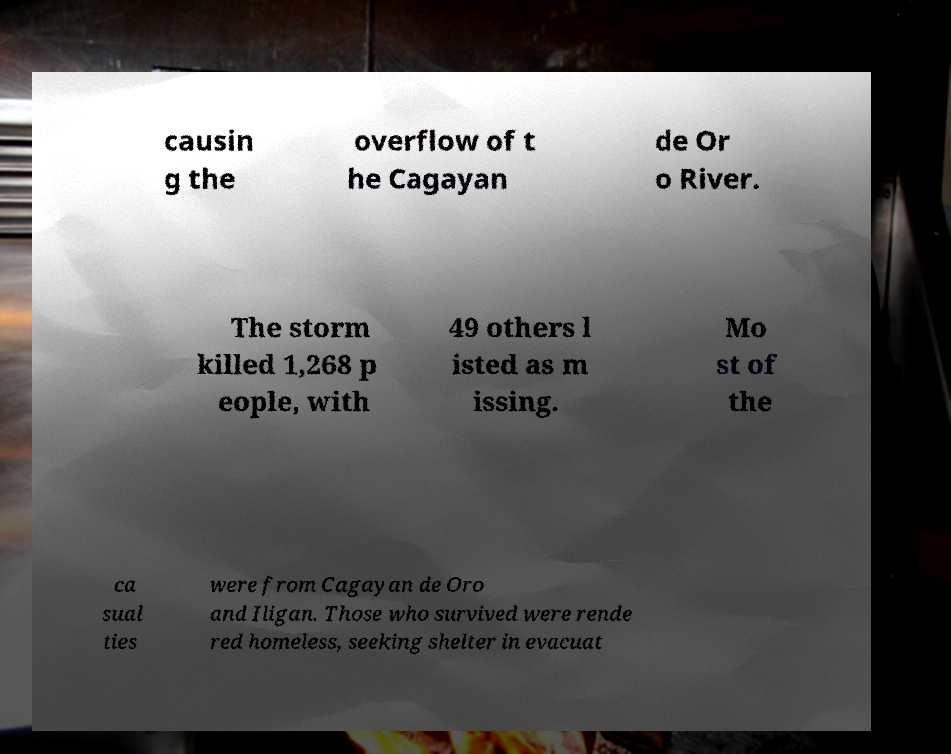Can you read and provide the text displayed in the image?This photo seems to have some interesting text. Can you extract and type it out for me? causin g the overflow of t he Cagayan de Or o River. The storm killed 1,268 p eople, with 49 others l isted as m issing. Mo st of the ca sual ties were from Cagayan de Oro and Iligan. Those who survived were rende red homeless, seeking shelter in evacuat 